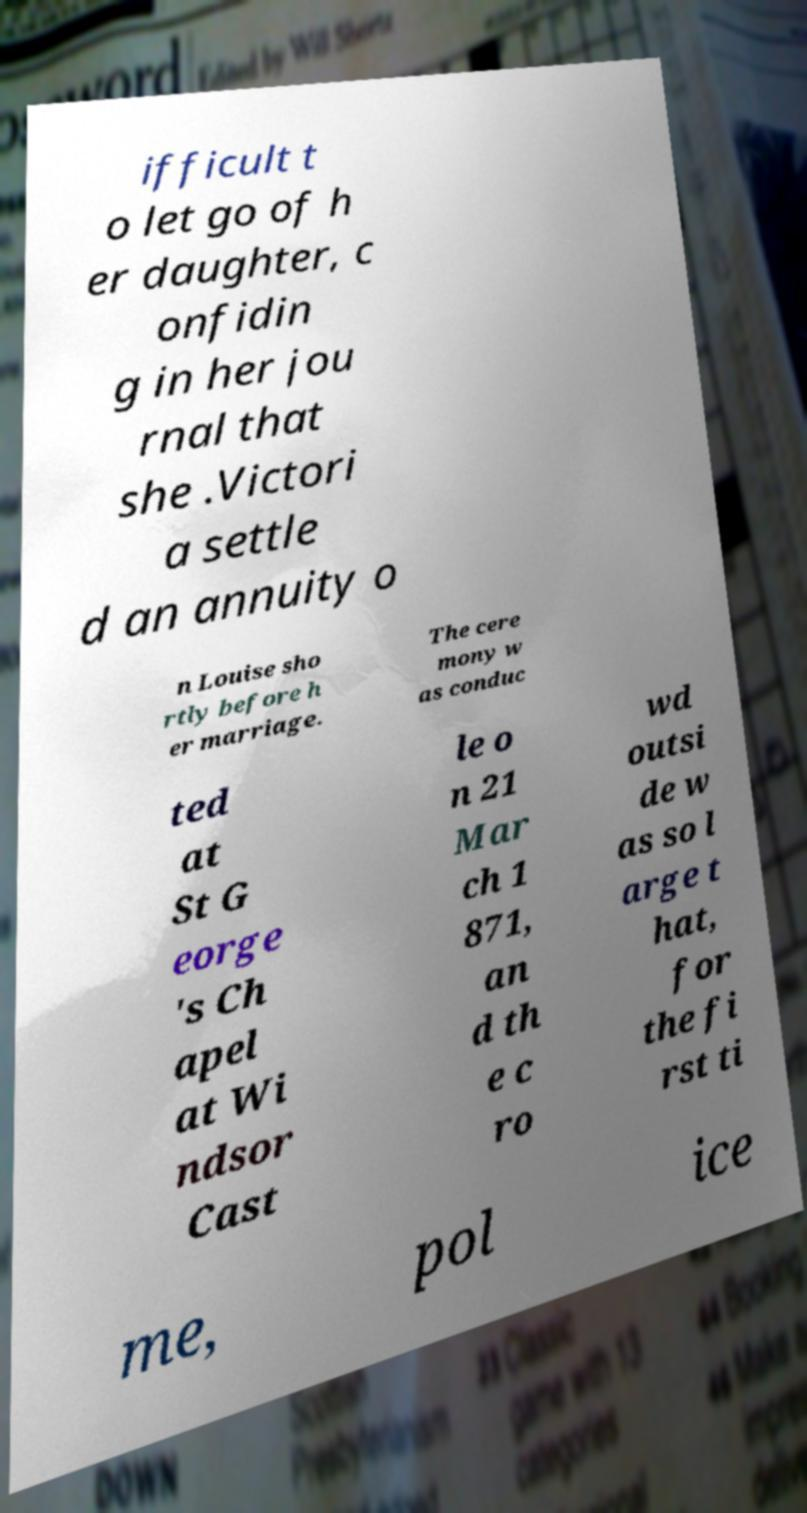For documentation purposes, I need the text within this image transcribed. Could you provide that? ifficult t o let go of h er daughter, c onfidin g in her jou rnal that she .Victori a settle d an annuity o n Louise sho rtly before h er marriage. The cere mony w as conduc ted at St G eorge 's Ch apel at Wi ndsor Cast le o n 21 Mar ch 1 871, an d th e c ro wd outsi de w as so l arge t hat, for the fi rst ti me, pol ice 